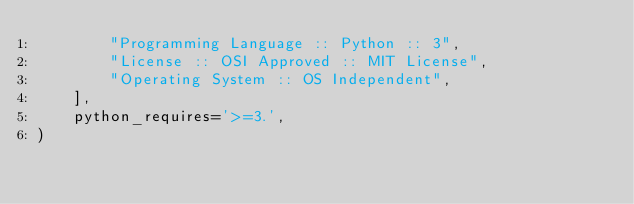Convert code to text. <code><loc_0><loc_0><loc_500><loc_500><_Python_>        "Programming Language :: Python :: 3",
        "License :: OSI Approved :: MIT License",
        "Operating System :: OS Independent",
    ],
    python_requires='>=3.',
)</code> 